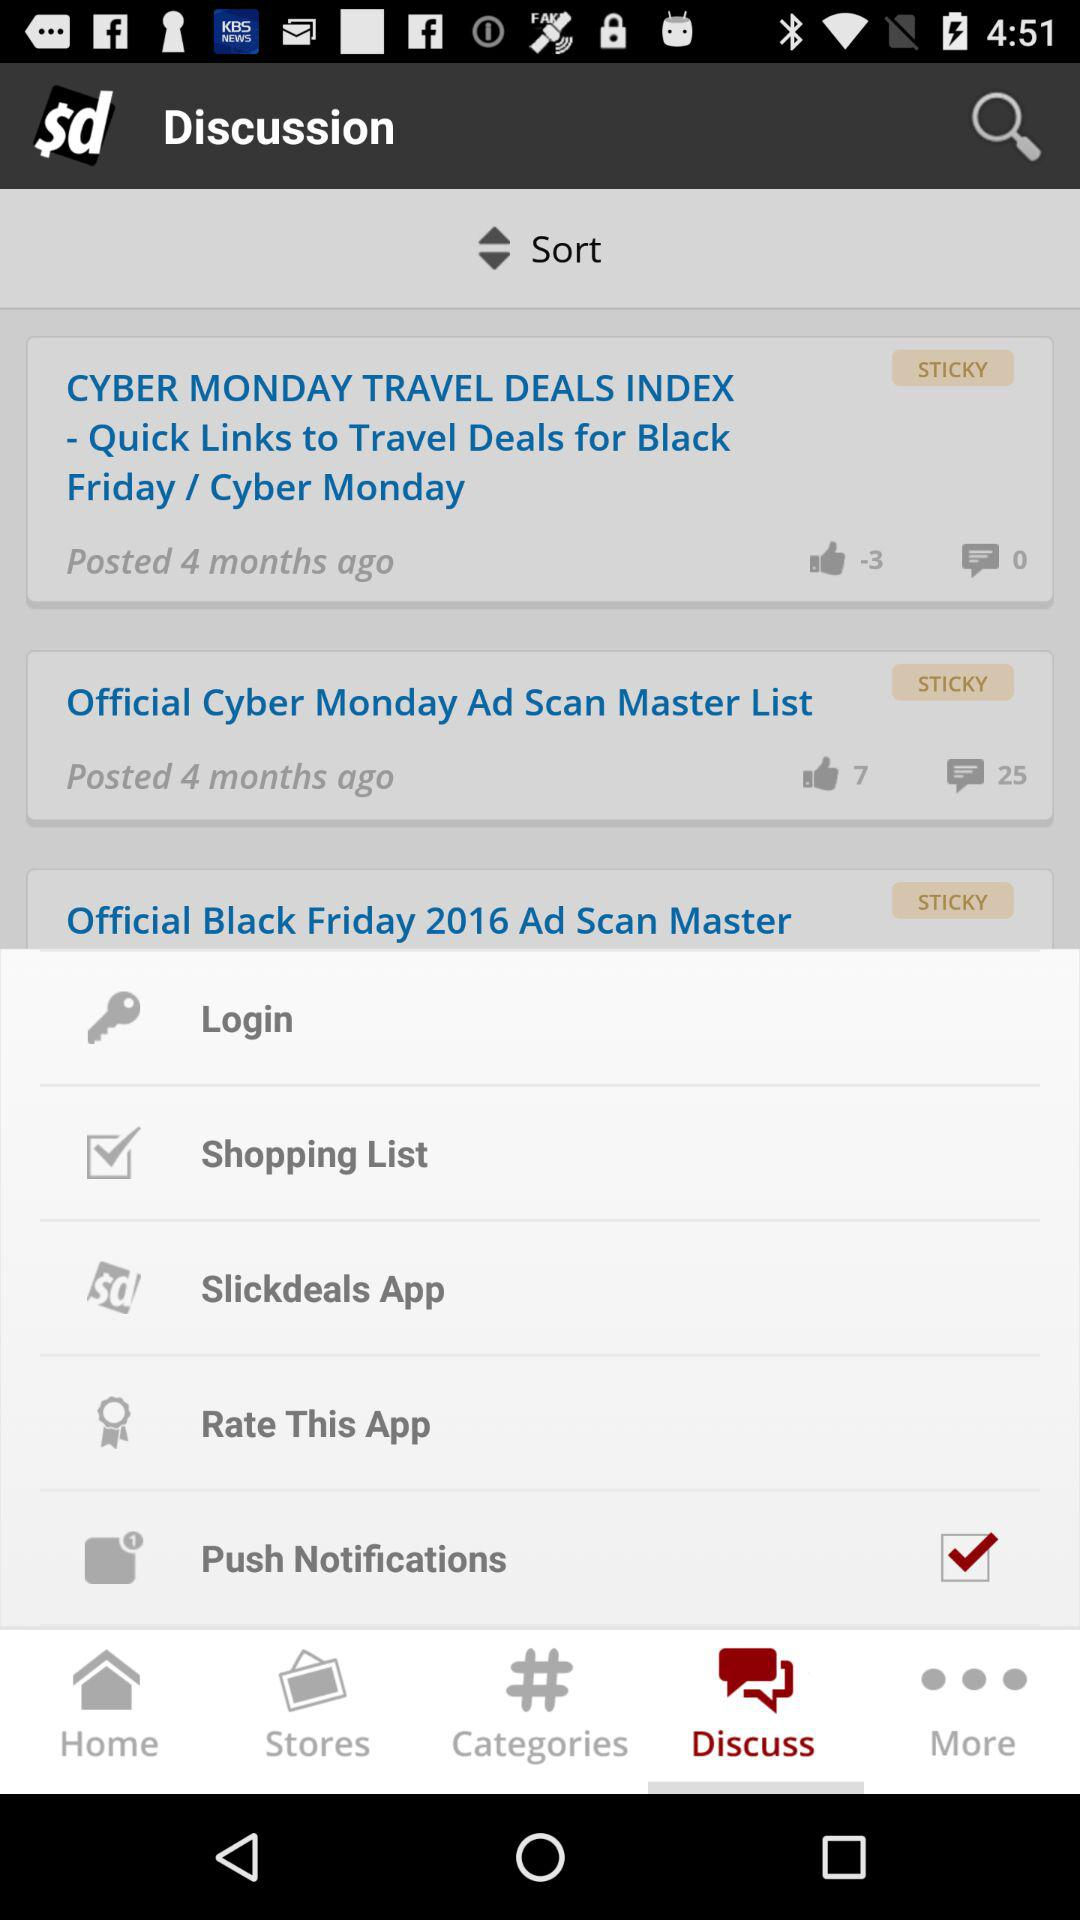How many items are in the shopping list?
When the provided information is insufficient, respond with <no answer>. <no answer> 